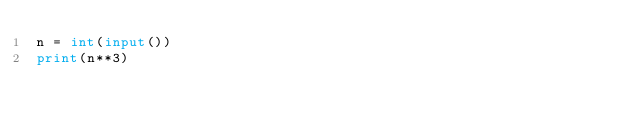Convert code to text. <code><loc_0><loc_0><loc_500><loc_500><_Python_>n = int(input())
print(n**3)
</code> 